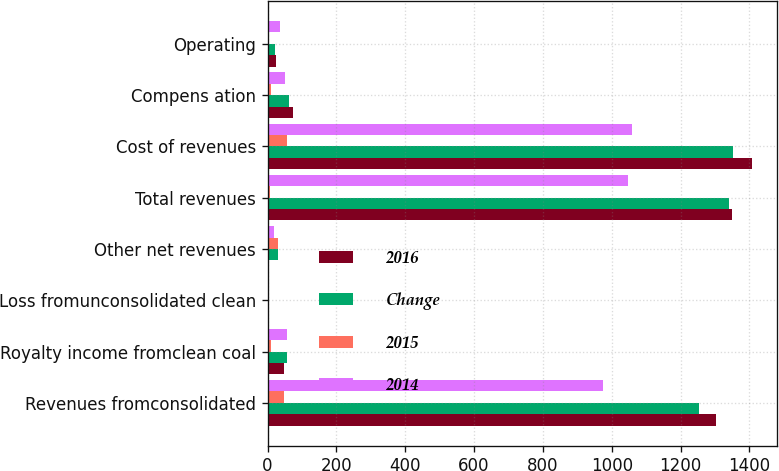Convert chart. <chart><loc_0><loc_0><loc_500><loc_500><stacked_bar_chart><ecel><fcel>Revenues fromconsolidated<fcel>Royalty income fromclean coal<fcel>Loss fromunconsolidated clean<fcel>Other net revenues<fcel>Total revenues<fcel>Cost of revenues<fcel>Compens ation<fcel>Operating<nl><fcel>2016<fcel>1303.8<fcel>48.1<fcel>1.8<fcel>1.3<fcel>1348.8<fcel>1408.6<fcel>72.6<fcel>25.4<nl><fcel>Change<fcel>1254.6<fcel>57.5<fcel>1.3<fcel>30.5<fcel>1341.3<fcel>1351.5<fcel>62<fcel>21.8<nl><fcel>2015<fcel>49.2<fcel>9.4<fcel>0.5<fcel>31.8<fcel>7.5<fcel>57.1<fcel>10.6<fcel>3.6<nl><fcel>2014<fcel>975.5<fcel>57.4<fcel>3.4<fcel>18.4<fcel>1047.9<fcel>1058.9<fcel>50.3<fcel>36.6<nl></chart> 